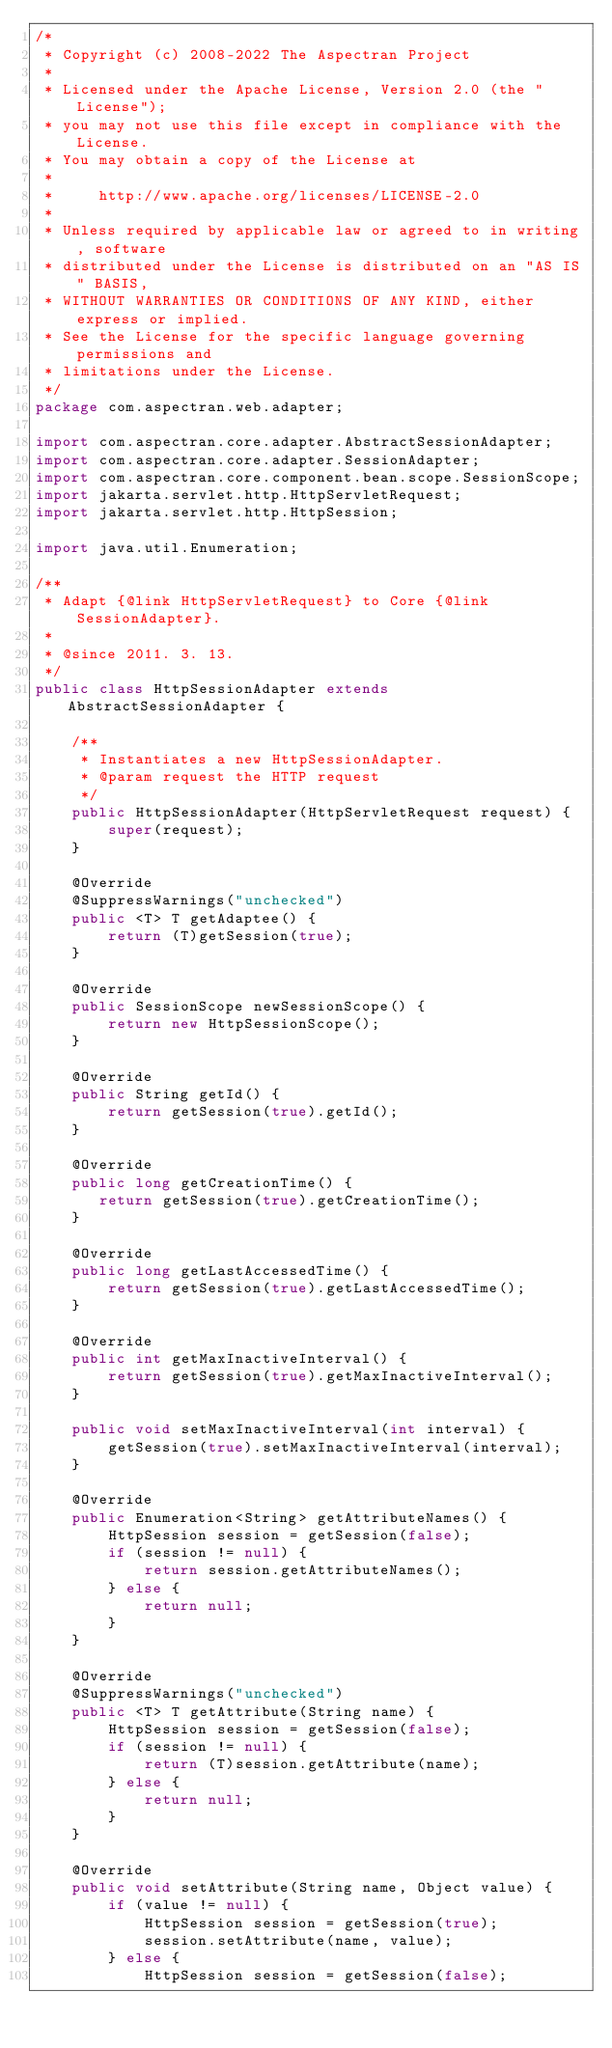Convert code to text. <code><loc_0><loc_0><loc_500><loc_500><_Java_>/*
 * Copyright (c) 2008-2022 The Aspectran Project
 *
 * Licensed under the Apache License, Version 2.0 (the "License");
 * you may not use this file except in compliance with the License.
 * You may obtain a copy of the License at
 *
 *     http://www.apache.org/licenses/LICENSE-2.0
 *
 * Unless required by applicable law or agreed to in writing, software
 * distributed under the License is distributed on an "AS IS" BASIS,
 * WITHOUT WARRANTIES OR CONDITIONS OF ANY KIND, either express or implied.
 * See the License for the specific language governing permissions and
 * limitations under the License.
 */
package com.aspectran.web.adapter;

import com.aspectran.core.adapter.AbstractSessionAdapter;
import com.aspectran.core.adapter.SessionAdapter;
import com.aspectran.core.component.bean.scope.SessionScope;
import jakarta.servlet.http.HttpServletRequest;
import jakarta.servlet.http.HttpSession;

import java.util.Enumeration;

/**
 * Adapt {@link HttpServletRequest} to Core {@link SessionAdapter}.
 *
 * @since 2011. 3. 13.
 */
public class HttpSessionAdapter extends AbstractSessionAdapter {

    /**
     * Instantiates a new HttpSessionAdapter.
     * @param request the HTTP request
     */
    public HttpSessionAdapter(HttpServletRequest request) {
        super(request);
    }

    @Override
    @SuppressWarnings("unchecked")
    public <T> T getAdaptee() {
        return (T)getSession(true);
    }

    @Override
    public SessionScope newSessionScope() {
        return new HttpSessionScope();
    }

    @Override
    public String getId() {
        return getSession(true).getId();
    }

    @Override
    public long getCreationTime() {
       return getSession(true).getCreationTime();
    }

    @Override
    public long getLastAccessedTime() {
        return getSession(true).getLastAccessedTime();
    }

    @Override
    public int getMaxInactiveInterval() {
        return getSession(true).getMaxInactiveInterval();
    }

    public void setMaxInactiveInterval(int interval) {
        getSession(true).setMaxInactiveInterval(interval);
    }

    @Override
    public Enumeration<String> getAttributeNames() {
        HttpSession session = getSession(false);
        if (session != null) {
            return session.getAttributeNames();
        } else {
            return null;
        }
    }

    @Override
    @SuppressWarnings("unchecked")
    public <T> T getAttribute(String name) {
        HttpSession session = getSession(false);
        if (session != null) {
            return (T)session.getAttribute(name);
        } else {
            return null;
        }
    }

    @Override
    public void setAttribute(String name, Object value) {
        if (value != null) {
            HttpSession session = getSession(true);
            session.setAttribute(name, value);
        } else {
            HttpSession session = getSession(false);</code> 